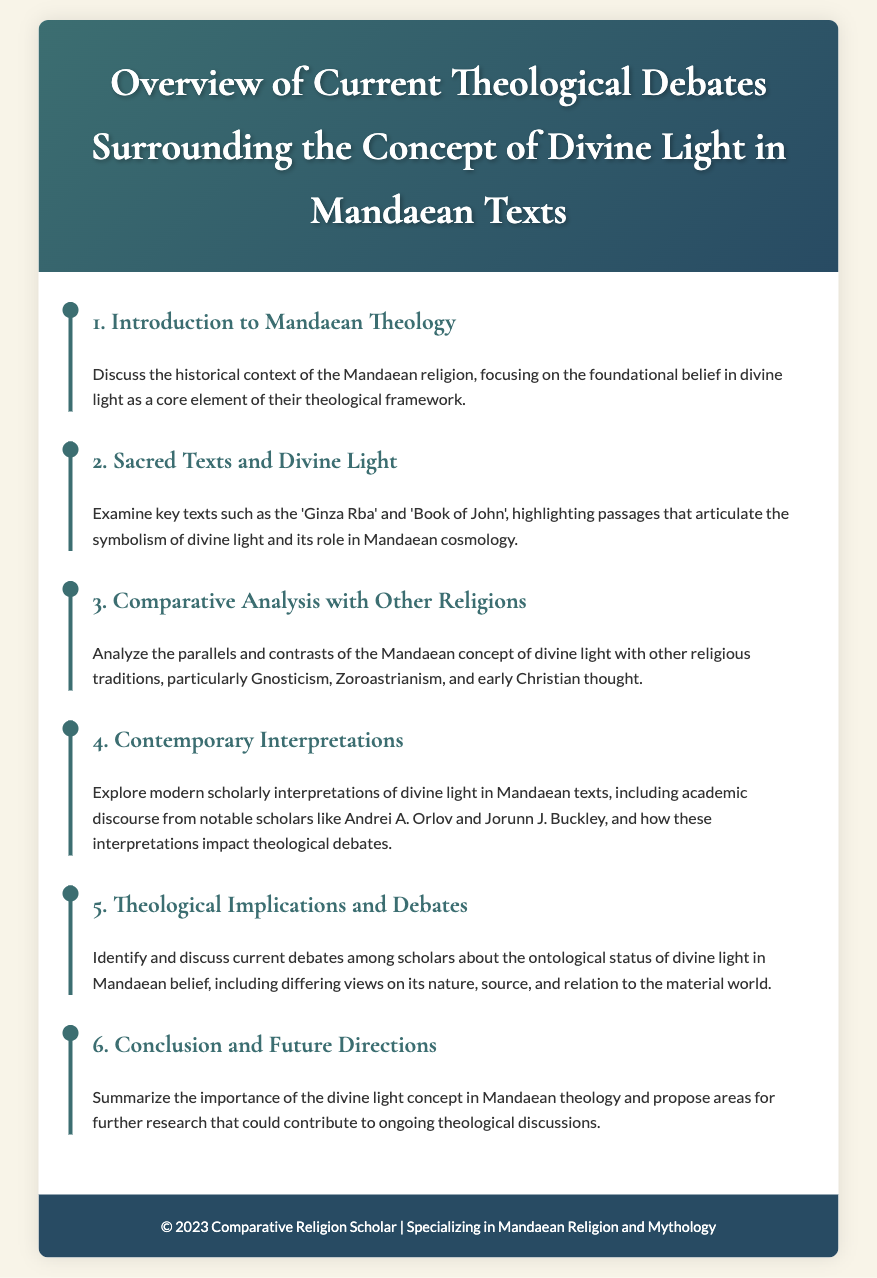What is the title of the document? The title is presented in the header of the document, which is a summary of its content.
Answer: Overview of Current Theological Debates Surrounding the Concept of Divine Light in Mandaean Texts Who is the target audience for this document? The footer suggests that the author is a Comparative Religion Scholar specializing in Mandaean Religion and Mythology, indicating the intended audience.
Answer: Comparative Religion Scholars Which two texts are highlighted in the agenda? The second agenda item mentions key texts that articulate the symbolism of divine light.
Answer: Ginza Rba and Book of John What is the focus of the third agenda item? The agenda item specifies exploring parallels and contrasts with other religious traditions regarding a specific concept.
Answer: Comparative Analysis with Other Religions Name one scholar mentioned in the fourth agenda item. The fourth agenda item discusses modern scholarly interpretations and names notable scholars in the field.
Answer: Andrei A. Orlov What does the fifth agenda item deal with? The fifth agenda item is focused on current scholarly debates concerning the ontological status of a concept within Mandaean belief.
Answer: Theological Implications and Debates What is proposed in the sixth agenda item? The agenda item suggests summarizing the importance of a concept and proposing further research directions.
Answer: Areas for further research How many agenda items are presented in the document? The agenda includes a specific number of items, each addressing different aspects of the overarching theme.
Answer: Six 